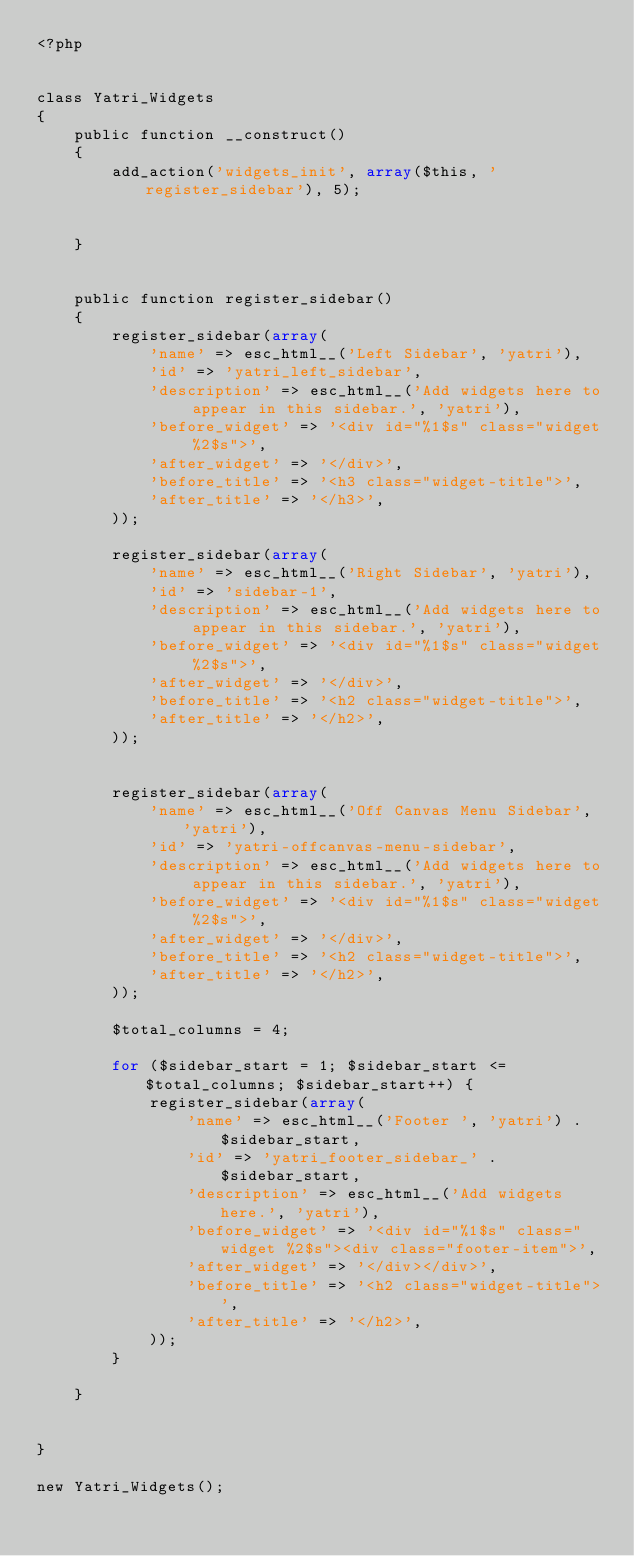Convert code to text. <code><loc_0><loc_0><loc_500><loc_500><_PHP_><?php


class Yatri_Widgets
{
    public function __construct()
    {
        add_action('widgets_init', array($this, 'register_sidebar'), 5);


    }


    public function register_sidebar()
    {
        register_sidebar(array(
            'name' => esc_html__('Left Sidebar', 'yatri'),
            'id' => 'yatri_left_sidebar',
            'description' => esc_html__('Add widgets here to appear in this sidebar.', 'yatri'),
            'before_widget' => '<div id="%1$s" class="widget %2$s">',
            'after_widget' => '</div>',
            'before_title' => '<h3 class="widget-title">',
            'after_title' => '</h3>',
        ));

        register_sidebar(array(
            'name' => esc_html__('Right Sidebar', 'yatri'),
            'id' => 'sidebar-1',
            'description' => esc_html__('Add widgets here to appear in this sidebar.', 'yatri'),
            'before_widget' => '<div id="%1$s" class="widget %2$s">',
            'after_widget' => '</div>',
            'before_title' => '<h2 class="widget-title">',
            'after_title' => '</h2>',
        ));


        register_sidebar(array(
            'name' => esc_html__('Off Canvas Menu Sidebar', 'yatri'),
            'id' => 'yatri-offcanvas-menu-sidebar',
            'description' => esc_html__('Add widgets here to appear in this sidebar.', 'yatri'),
            'before_widget' => '<div id="%1$s" class="widget %2$s">',
            'after_widget' => '</div>',
            'before_title' => '<h2 class="widget-title">',
            'after_title' => '</h2>',
        ));

        $total_columns = 4;

        for ($sidebar_start = 1; $sidebar_start <= $total_columns; $sidebar_start++) {
            register_sidebar(array(
                'name' => esc_html__('Footer ', 'yatri') . $sidebar_start,
                'id' => 'yatri_footer_sidebar_' . $sidebar_start,
                'description' => esc_html__('Add widgets here.', 'yatri'),
                'before_widget' => '<div id="%1$s" class="widget %2$s"><div class="footer-item">',
                'after_widget' => '</div></div>',
                'before_title' => '<h2 class="widget-title">',
                'after_title' => '</h2>',
            ));
        }

    }


}

new Yatri_Widgets();</code> 